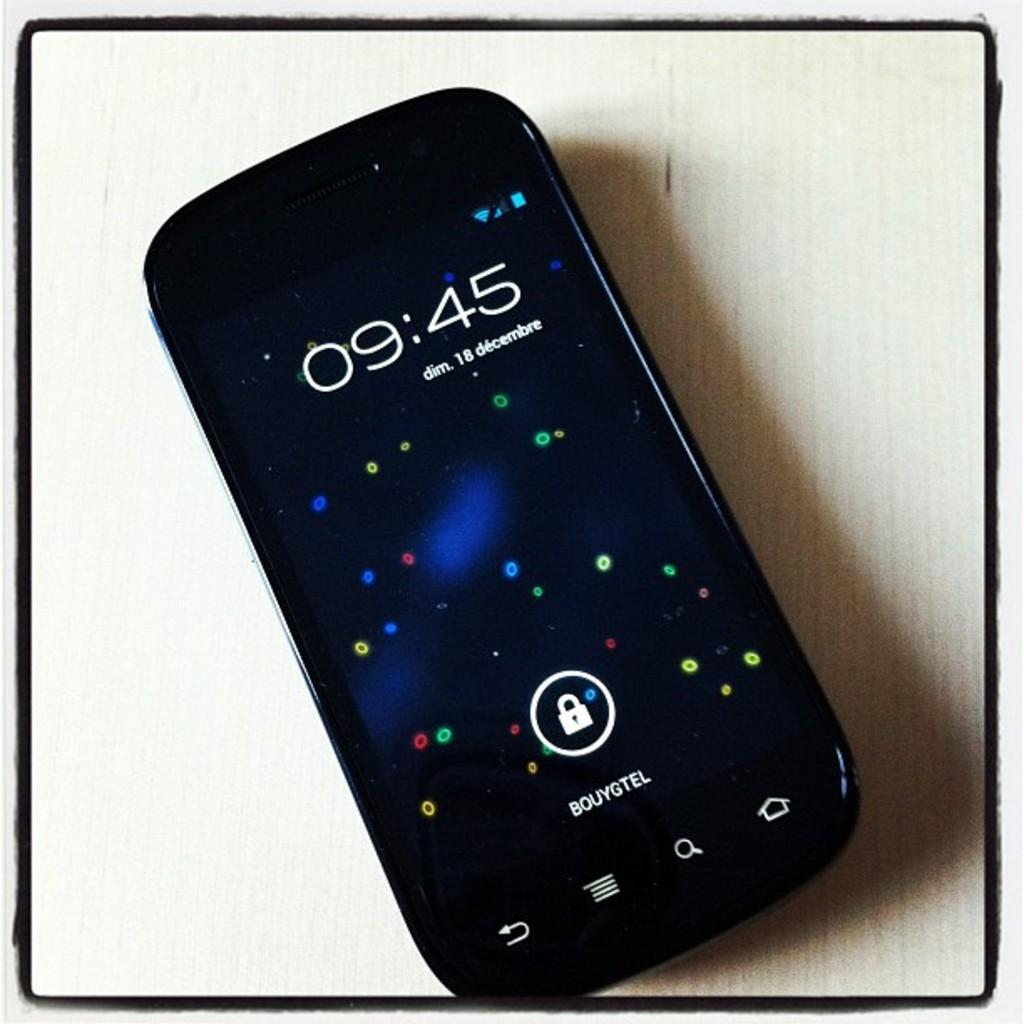<image>
Relay a brief, clear account of the picture shown. A phone has the word Bouygtel under the unlock icon. 